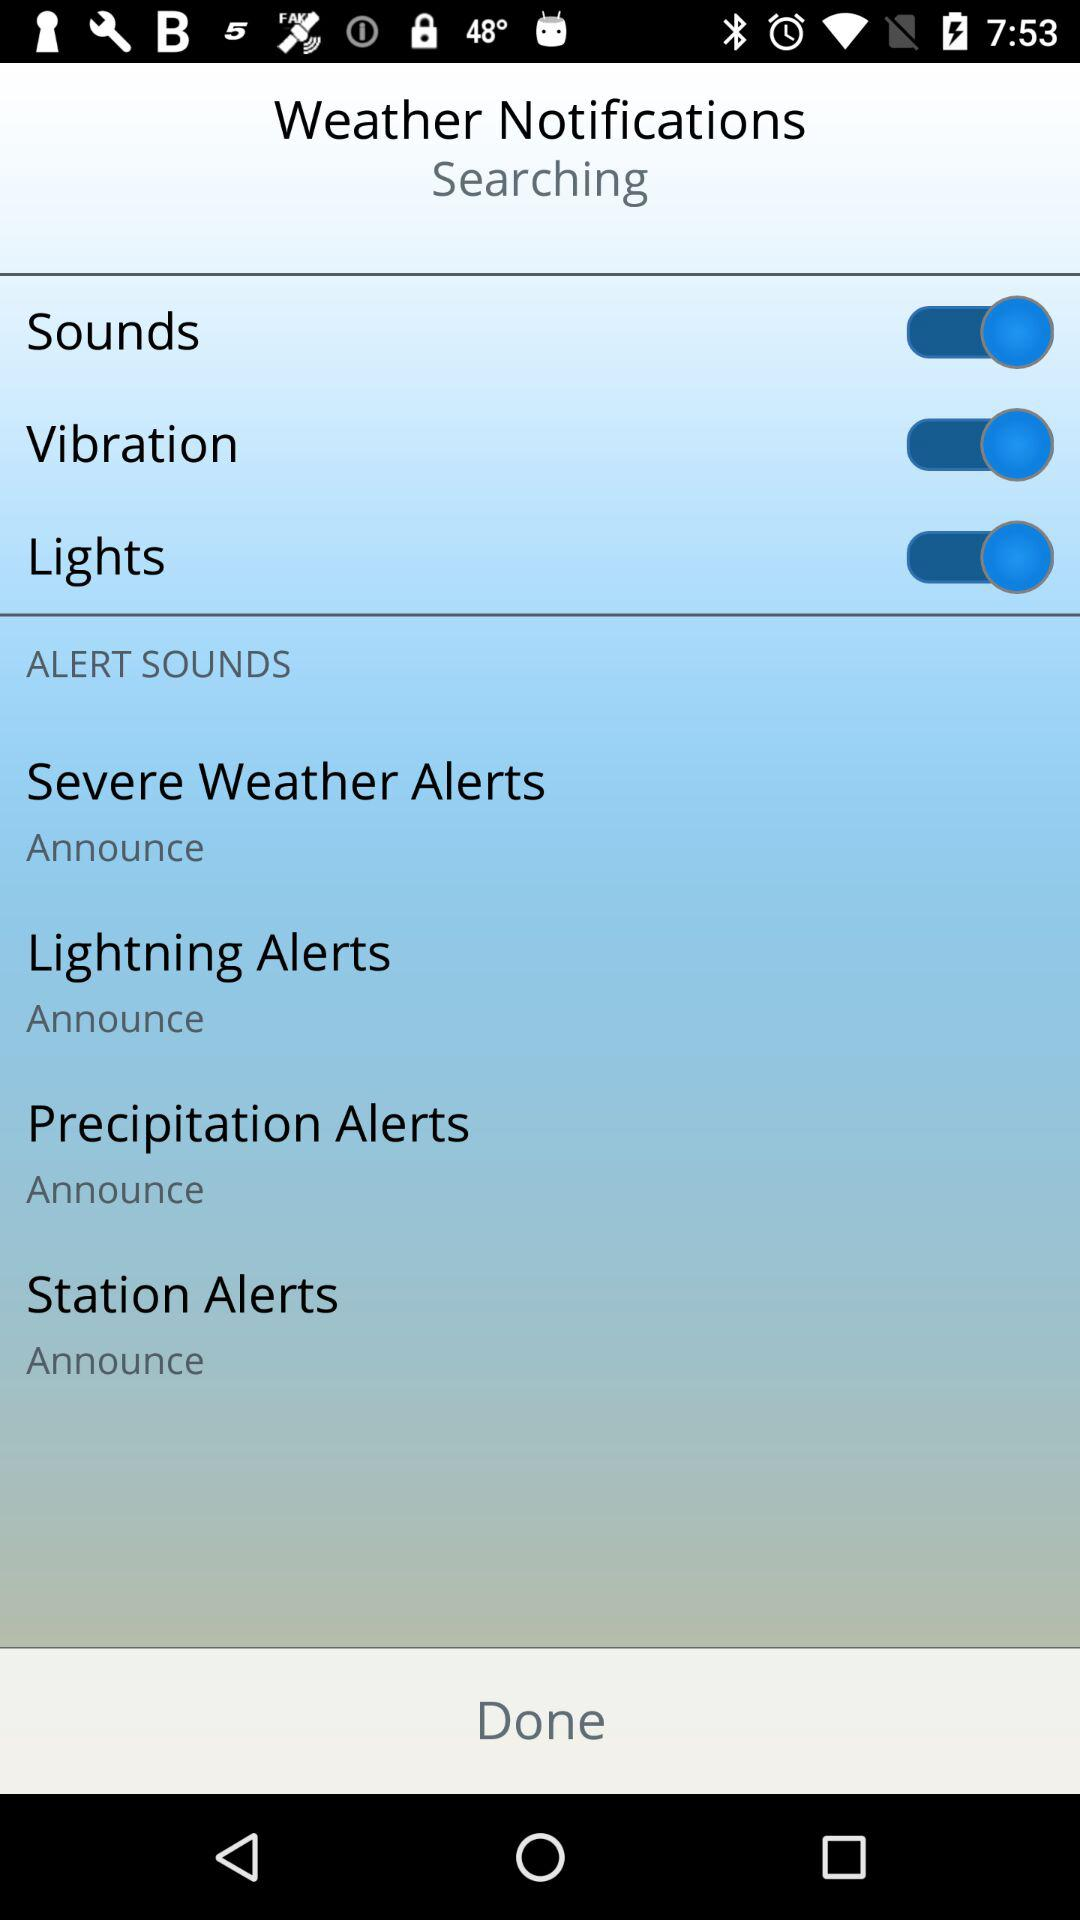What is the status of the "Lights"? The status is "on". 